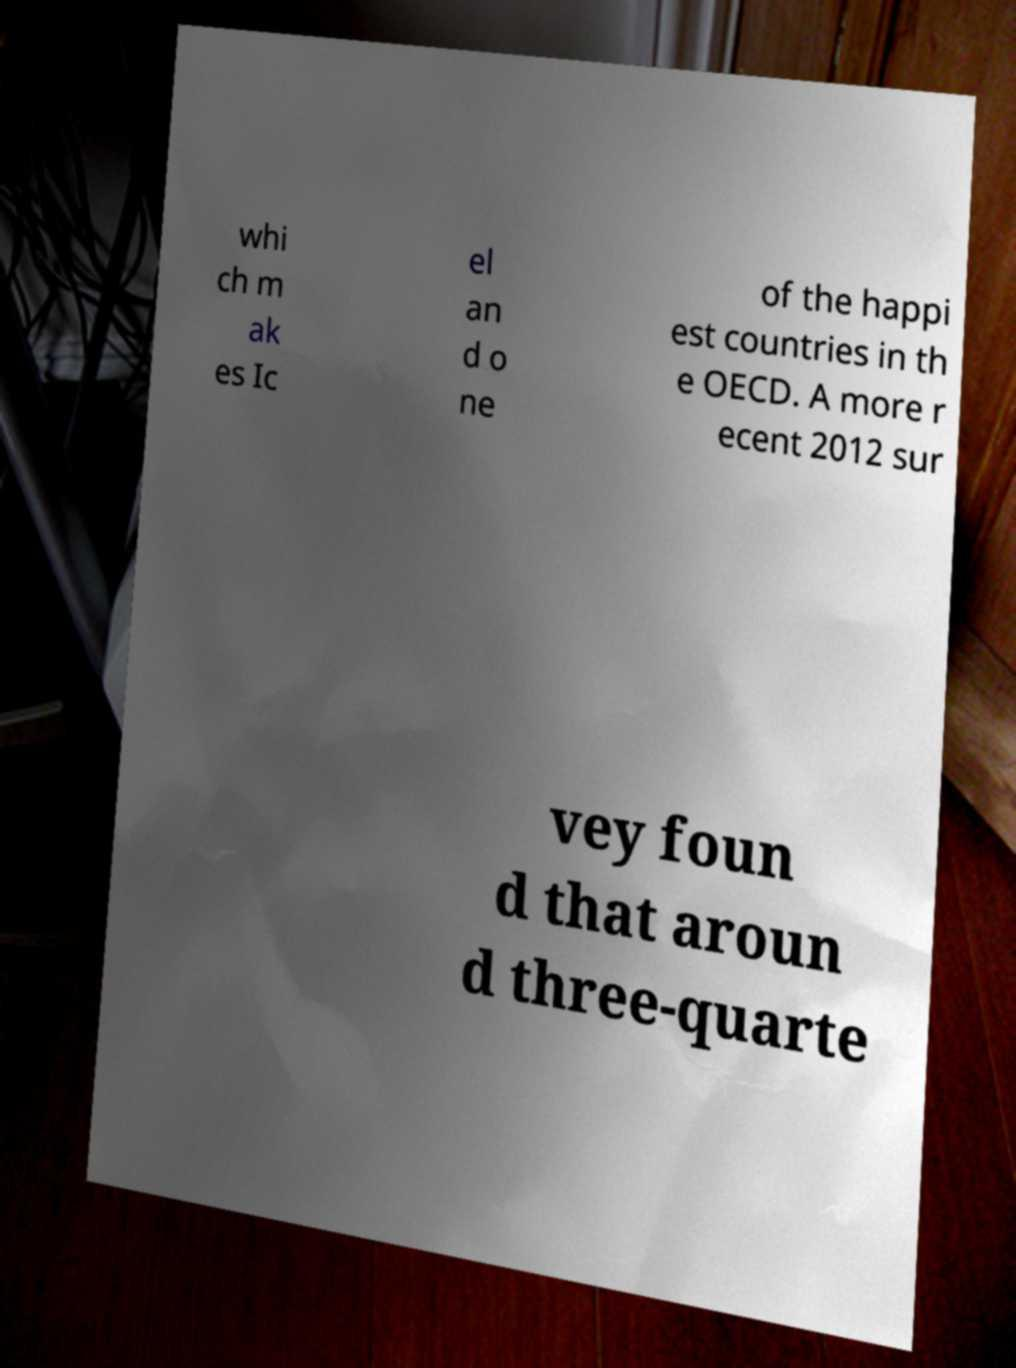Please identify and transcribe the text found in this image. whi ch m ak es Ic el an d o ne of the happi est countries in th e OECD. A more r ecent 2012 sur vey foun d that aroun d three-quarte 